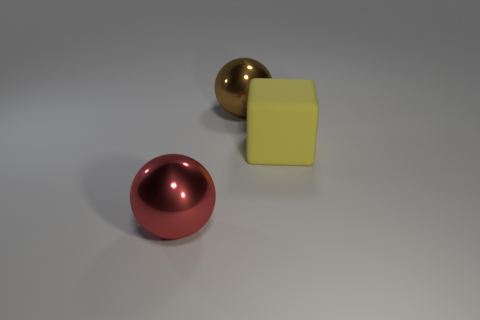How many things are either small green shiny balls or large things?
Your answer should be compact. 3. Do the big brown thing and the large ball that is in front of the yellow matte cube have the same material?
Provide a succinct answer. Yes. There is a sphere that is behind the cube; what size is it?
Ensure brevity in your answer.  Large. Is the number of big gray things less than the number of large yellow matte objects?
Offer a very short reply. Yes. What is the shape of the large thing that is both in front of the big brown thing and behind the red ball?
Offer a terse response. Cube. The object on the left side of the big sphere behind the big red metal ball is what shape?
Your answer should be compact. Sphere. Is the brown metallic thing the same shape as the yellow rubber object?
Offer a very short reply. No. How many yellow matte objects are on the left side of the large ball that is in front of the object that is behind the rubber thing?
Give a very brief answer. 0. What is the material of the large sphere on the left side of the large shiny ball that is behind the big shiny ball in front of the yellow cube?
Provide a short and direct response. Metal. What number of things are large shiny objects that are in front of the yellow cube or red objects?
Offer a very short reply. 1. 